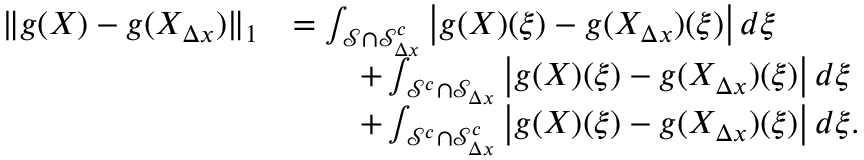Convert formula to latex. <formula><loc_0><loc_0><loc_500><loc_500>\begin{array} { r l } { \| g ( X ) - g ( X _ { \Delta x } ) \| _ { 1 } } & { = \int _ { \mathcal { S } \cap \mathcal { S } _ { \Delta x } ^ { c } } \left | g ( X ) ( \xi ) - g ( X _ { \Delta x } ) ( \xi ) \right | d \xi } \\ & { \quad + \int _ { \mathcal { S } ^ { c } \cap \mathcal { S } _ { \Delta x } } \left | g ( X ) ( \xi ) - g ( X _ { \Delta x } ) ( \xi ) \right | d \xi } \\ & { \quad + \int _ { \mathcal { S } ^ { c } \cap \mathcal { S } _ { \Delta x } ^ { c } } \left | g ( X ) ( \xi ) - g ( X _ { \Delta x } ) ( \xi ) \right | d \xi . } \end{array}</formula> 